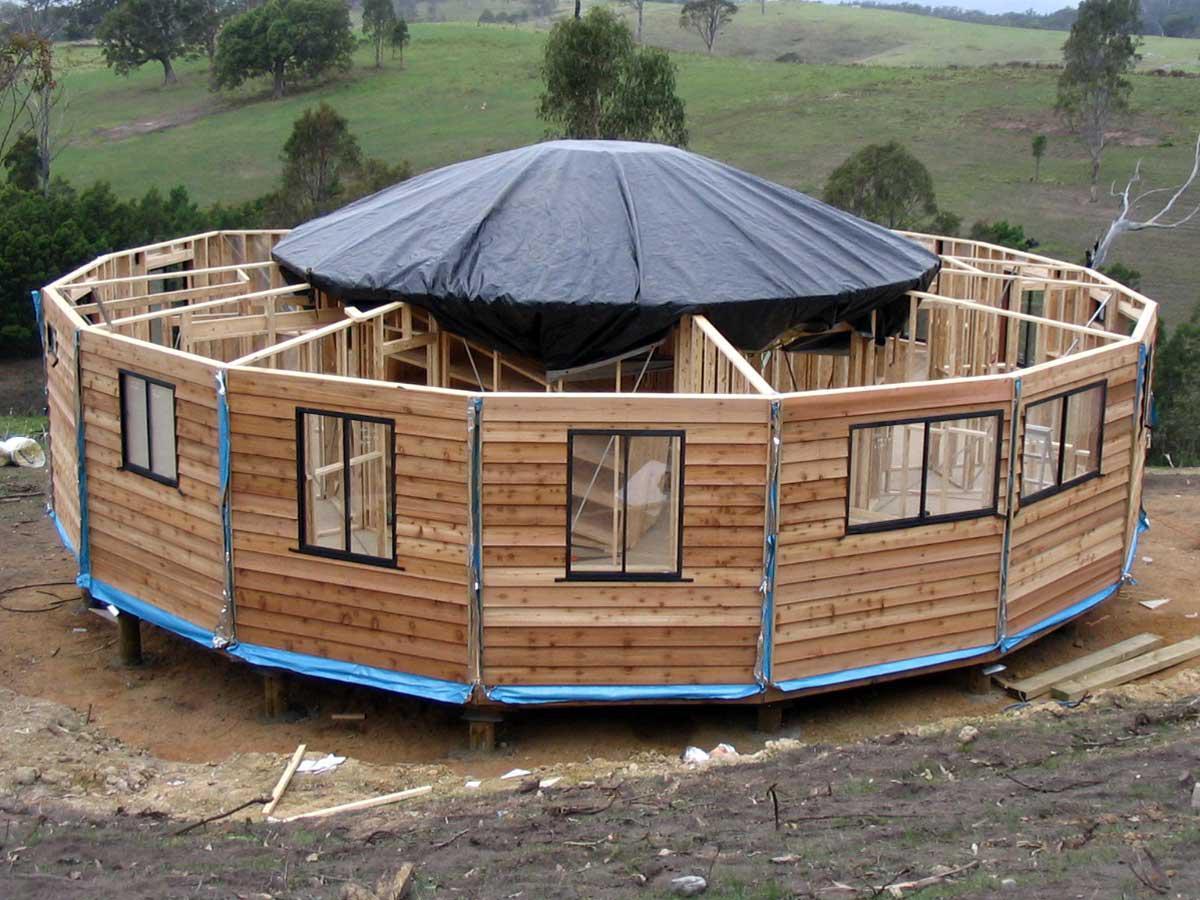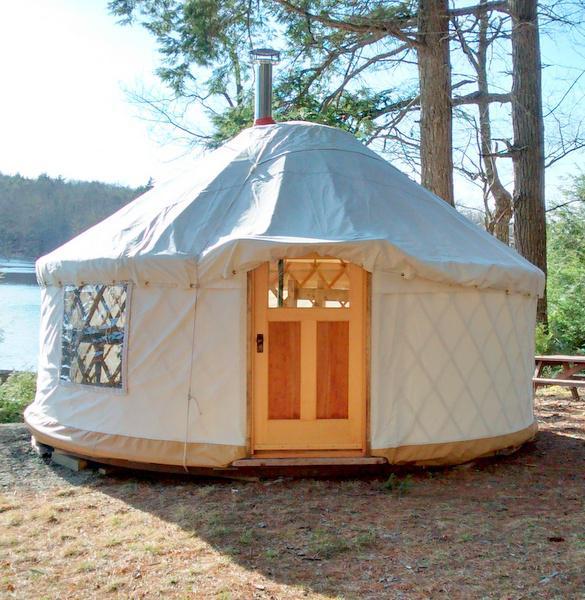The first image is the image on the left, the second image is the image on the right. Analyze the images presented: Is the assertion "One image shows a cylindrical olive-green building with one door." valid? Answer yes or no. No. 